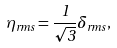Convert formula to latex. <formula><loc_0><loc_0><loc_500><loc_500>\eta _ { r m s } = \frac { 1 } { \sqrt { 3 } } \delta _ { r m s } ,</formula> 